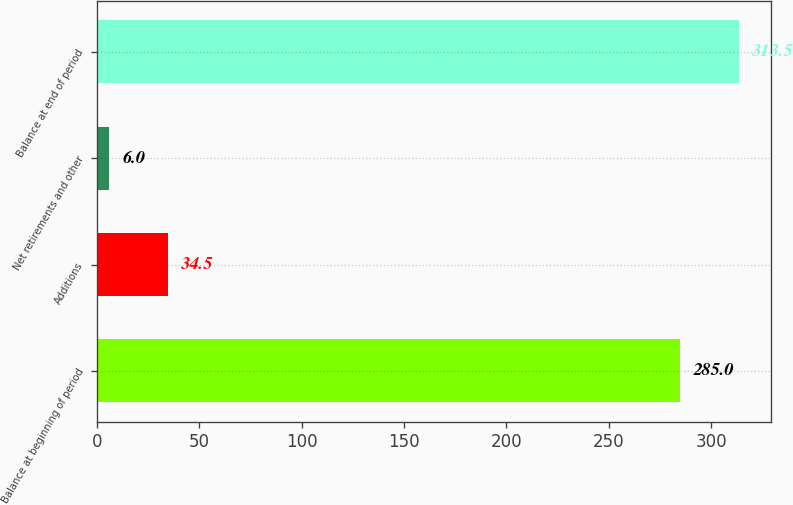<chart> <loc_0><loc_0><loc_500><loc_500><bar_chart><fcel>Balance at beginning of period<fcel>Additions<fcel>Net retirements and other<fcel>Balance at end of period<nl><fcel>285<fcel>34.5<fcel>6<fcel>313.5<nl></chart> 